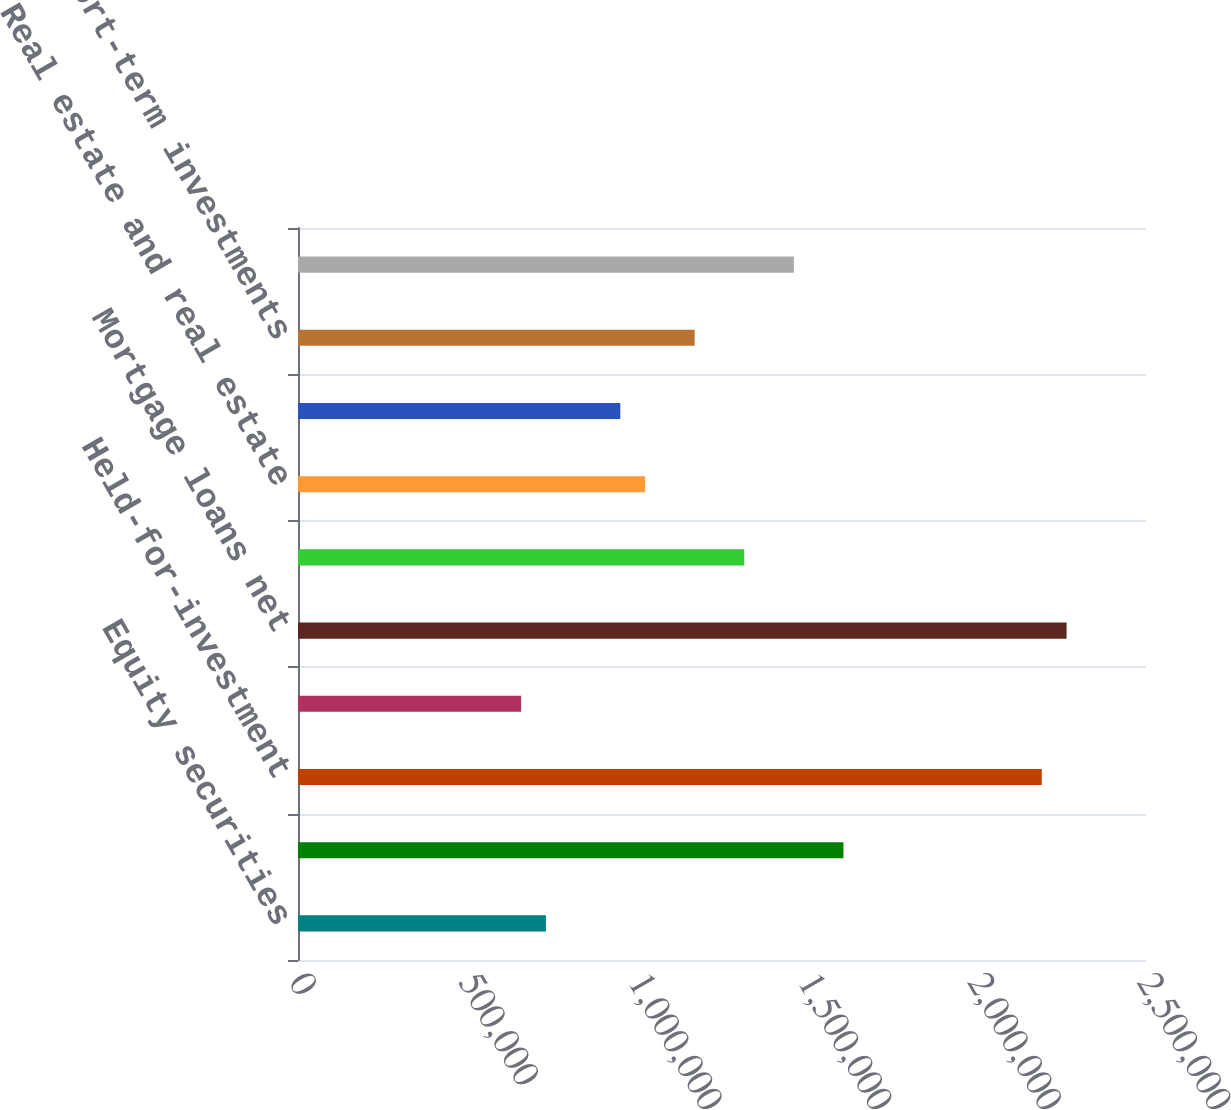Convert chart. <chart><loc_0><loc_0><loc_500><loc_500><bar_chart><fcel>Equity securities<fcel>Trading and other securities<fcel>Held-for-investment<fcel>Held-for-sale principally at<fcel>Mortgage loans net<fcel>Policy loans<fcel>Real estate and real estate<fcel>Other limited partnership<fcel>Short-term investments<fcel>Other invested assets<nl><fcel>730906<fcel>1.60799e+06<fcel>2.19272e+06<fcel>657816<fcel>2.26581e+06<fcel>1.31563e+06<fcel>1.02327e+06<fcel>950178<fcel>1.16945e+06<fcel>1.46181e+06<nl></chart> 